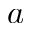<formula> <loc_0><loc_0><loc_500><loc_500>a</formula> 